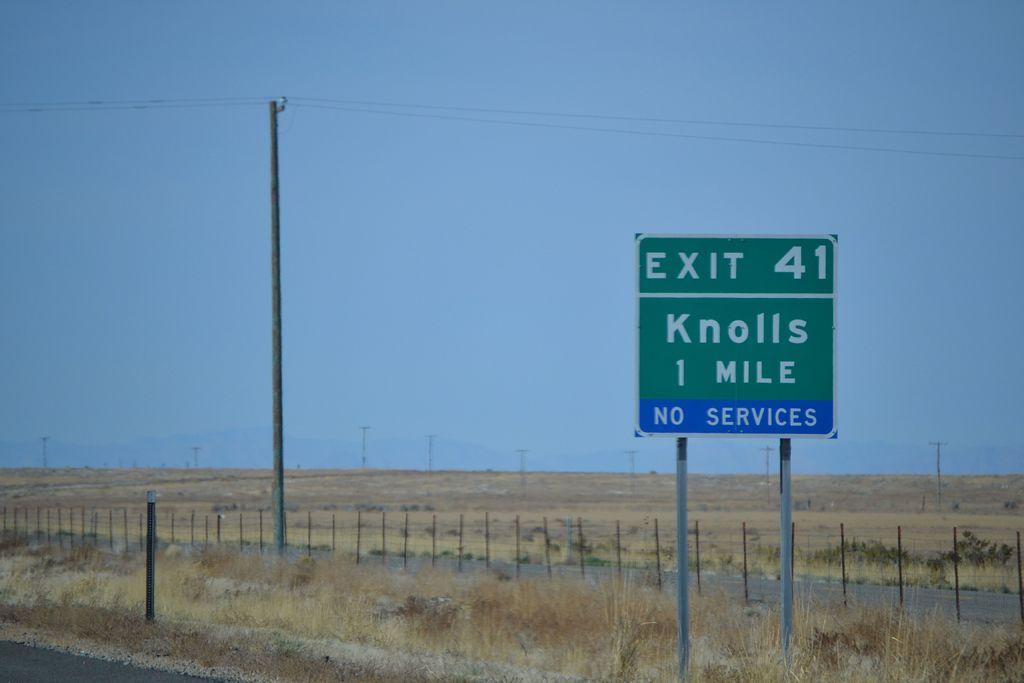How many miles is knolls?
Make the answer very short. 1. 